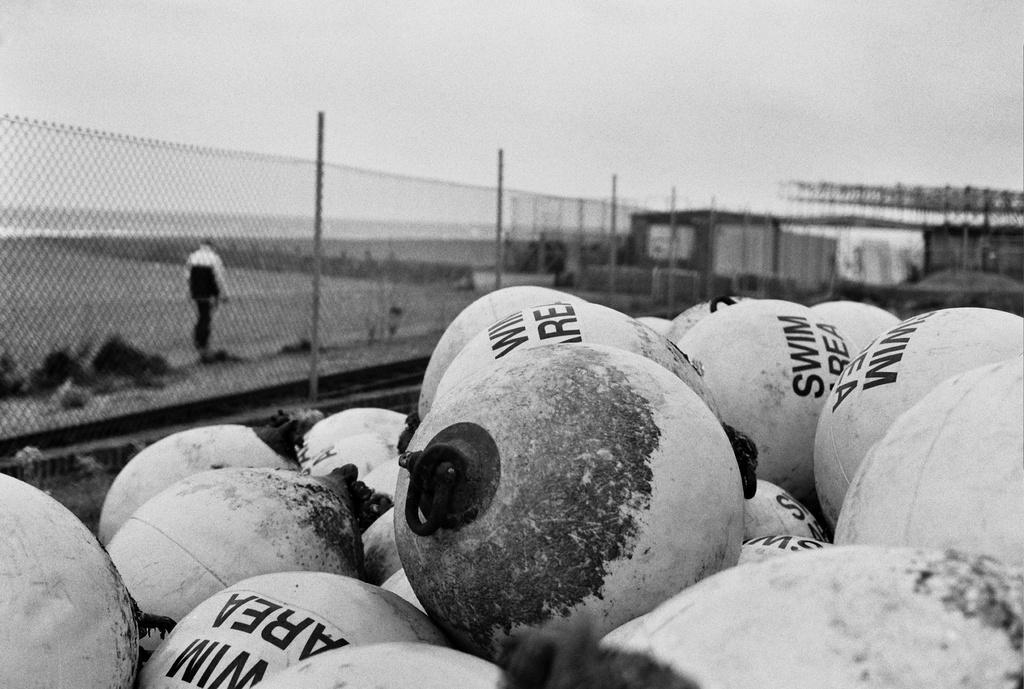Please provide a concise description of this image. In this picture there are objects in the foreground and there is text on the objects. At the back there is a person walking behind the fence and there is a building. At the top there is sky. At the bottom there are plants and there is ground. 